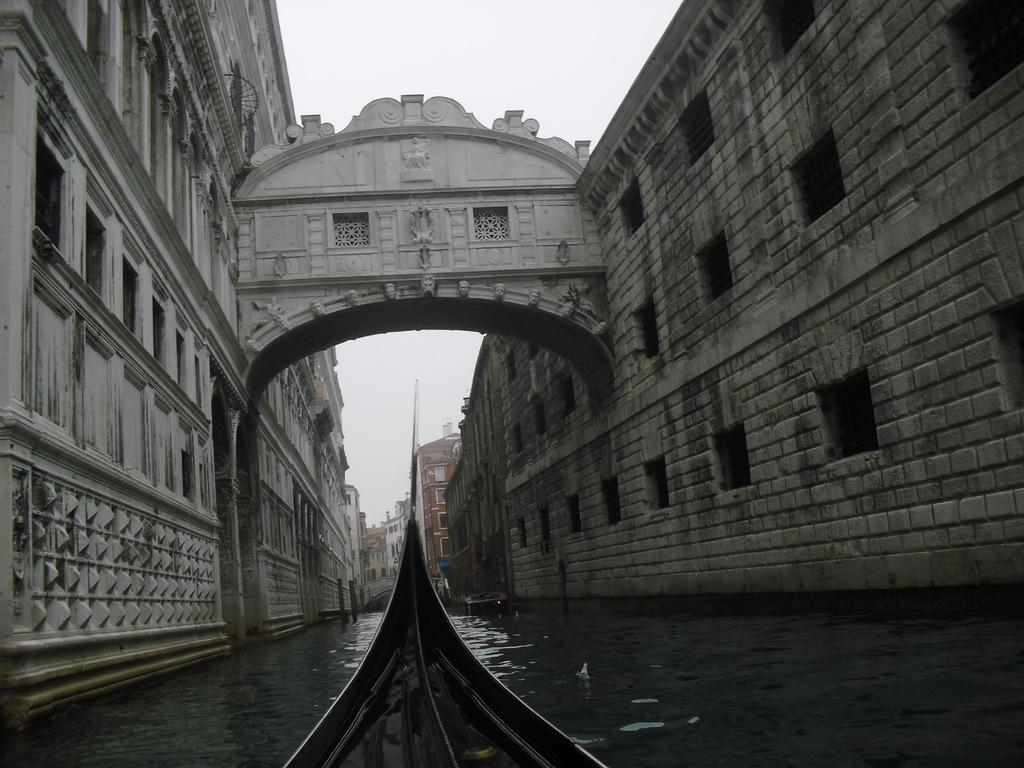What part of a boat can be seen at the bottom of the image? There is a part of a boat at the bottom of the image. What is the primary setting of the image? The image features water, suggesting a water-based setting. What type of structures are visible on the sides of the image? There are buildings with windows on the sides of the image. What architectural feature can be seen in the image? There is an arch in the image. What is visible in the background of the image? The sky is visible in the background of the image. What type of popcorn is being cooked on the stove in the image? There is no popcorn or stove present in the image. What month is it in the image? The image does not provide any information about the month or time of year. 